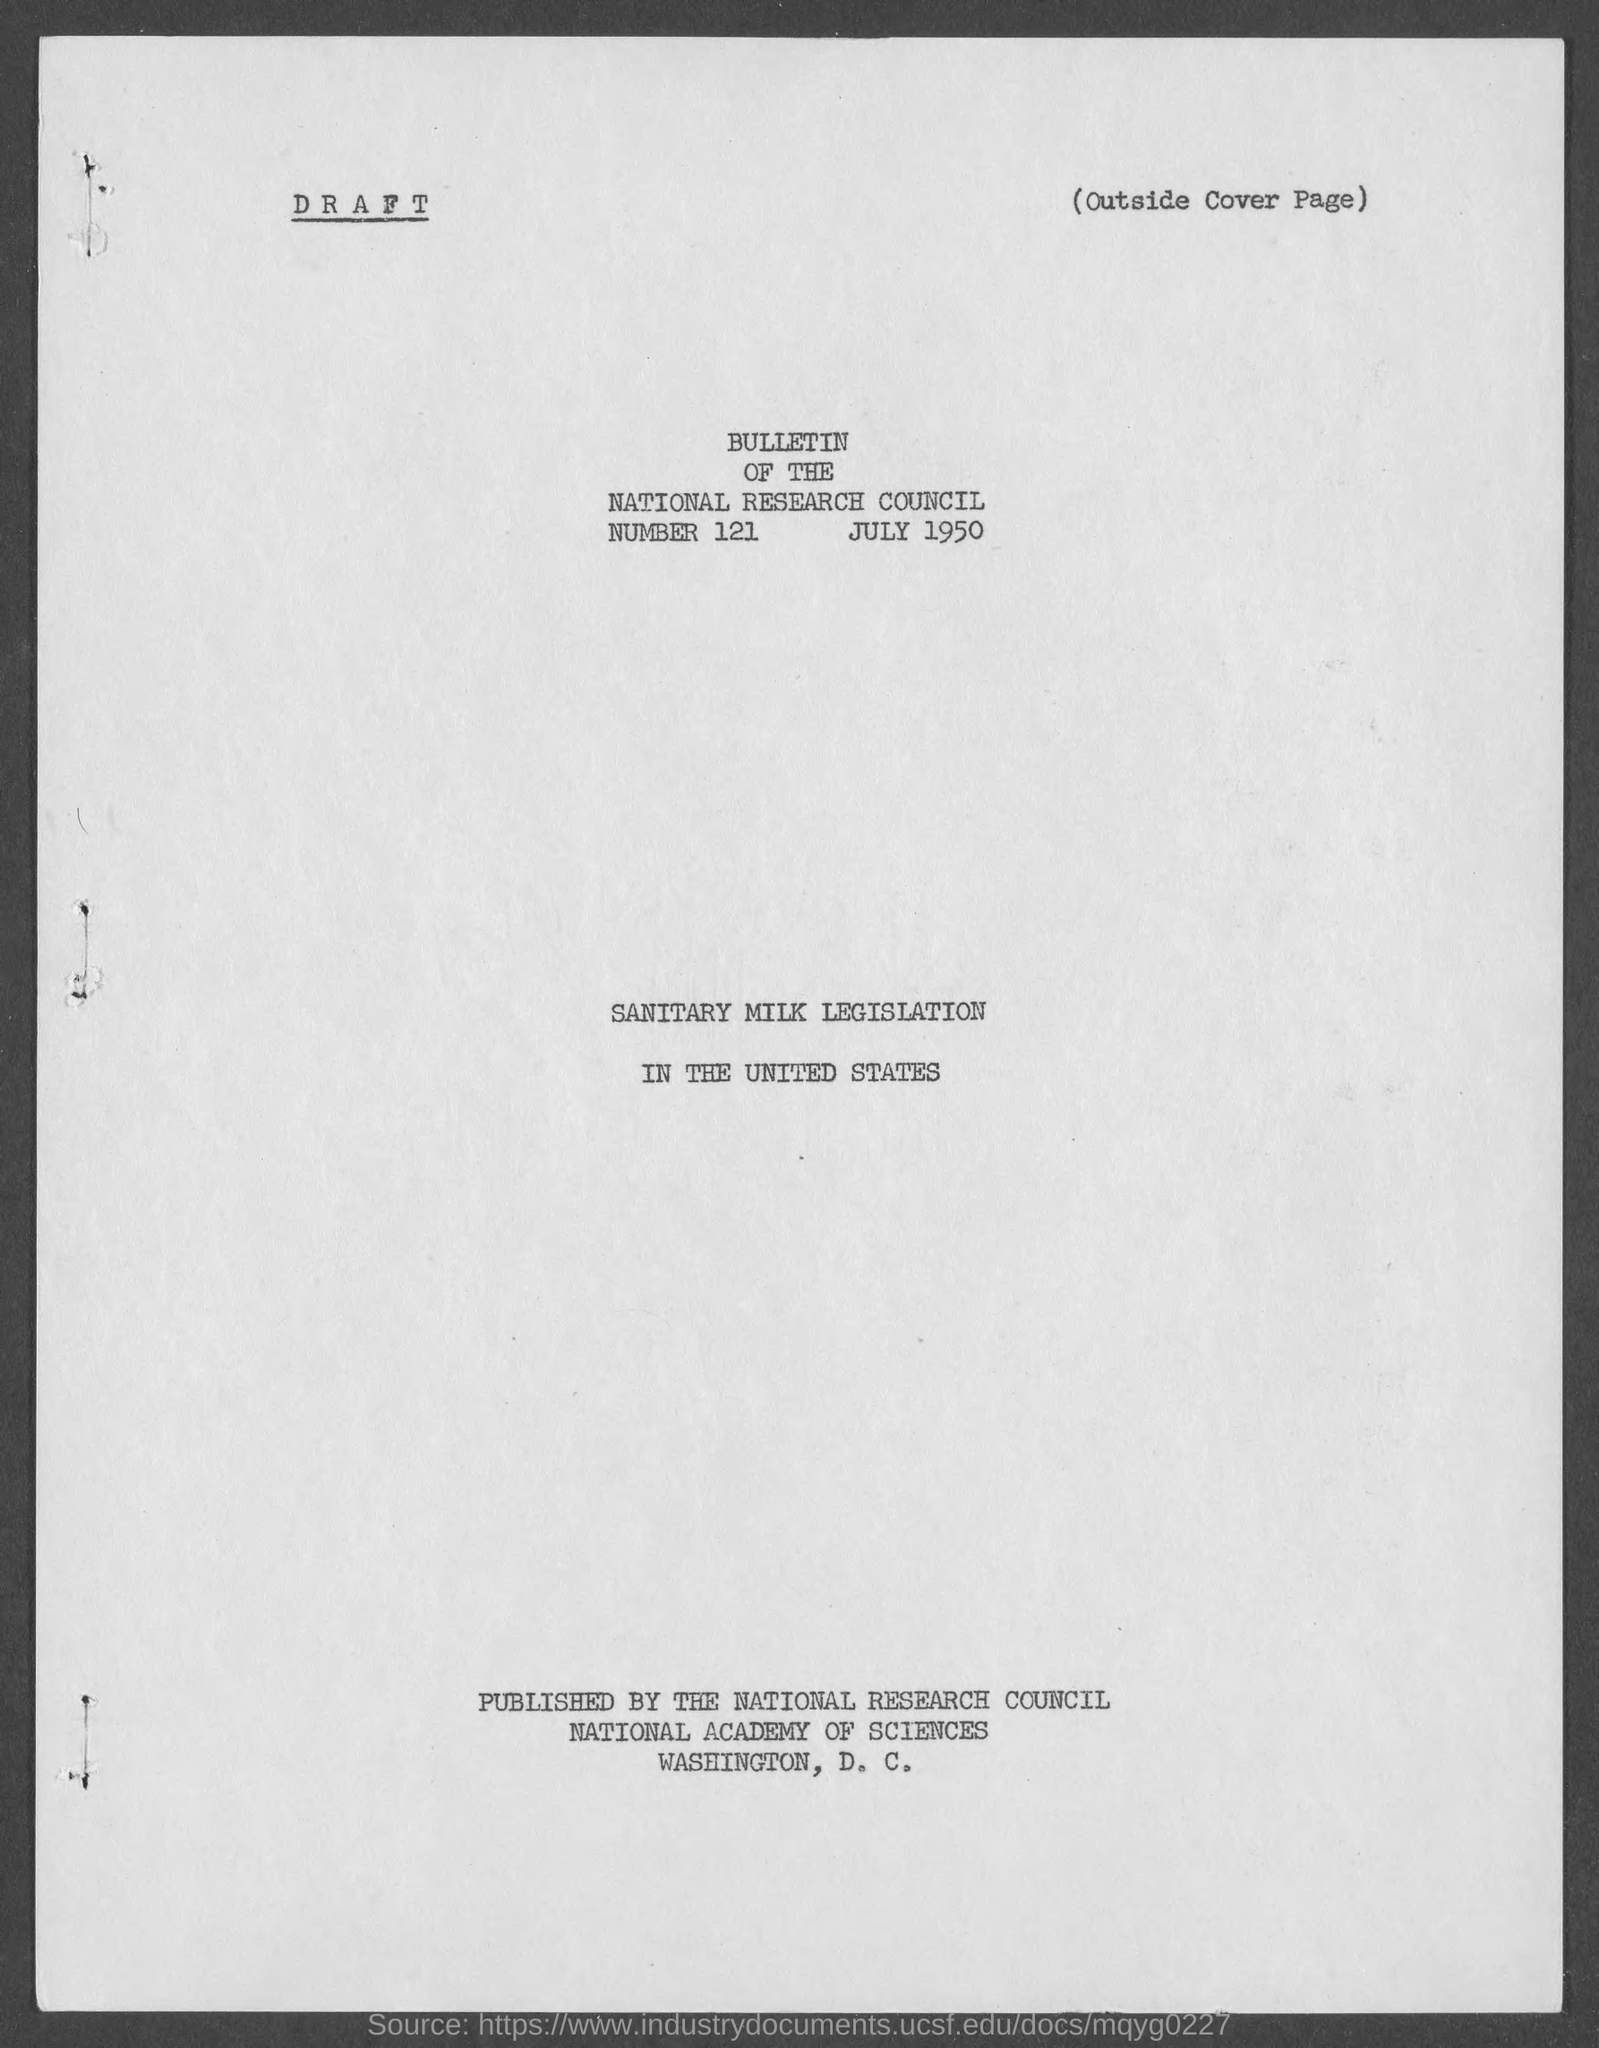Mention a couple of crucial points in this snapshot. The bulletin number of the National Research Council is 121. 